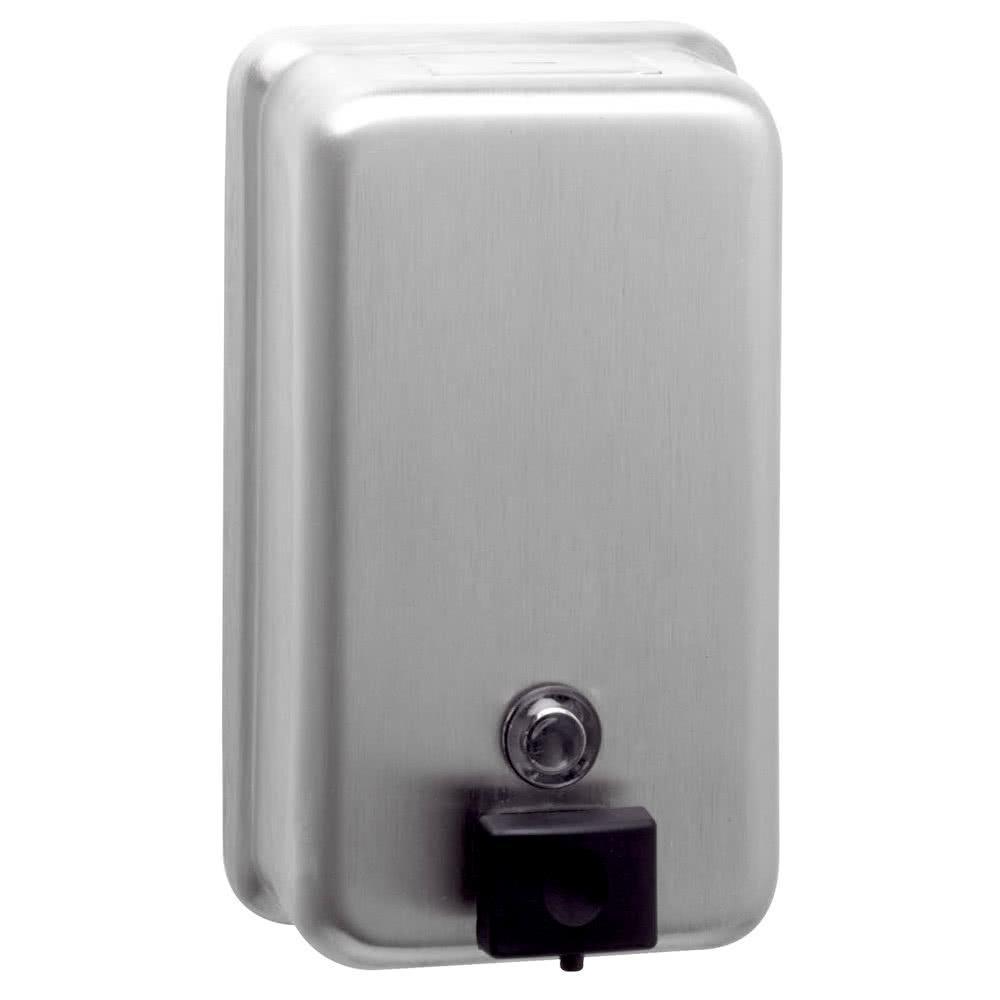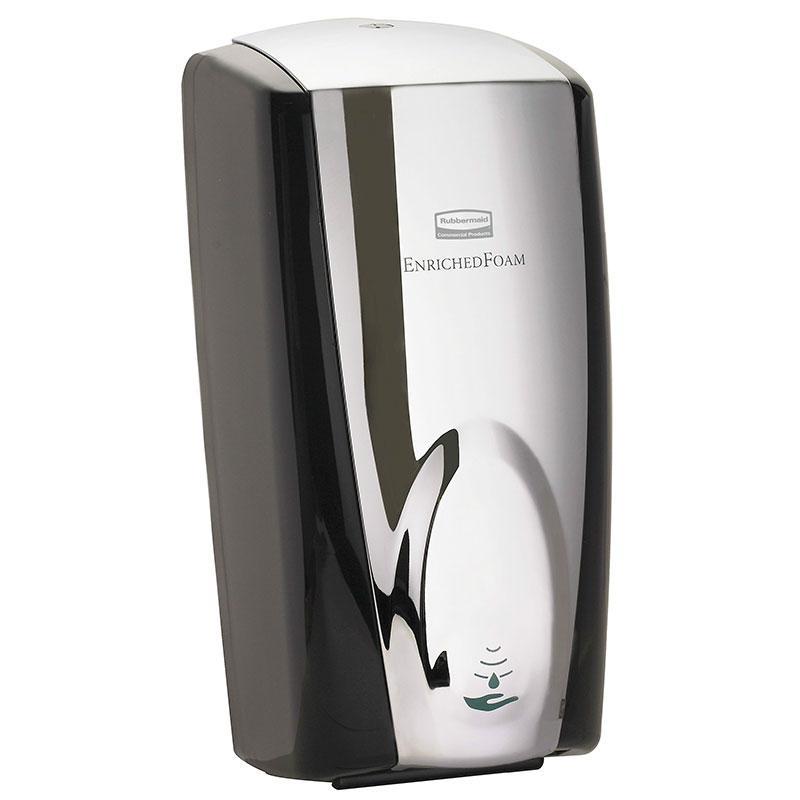The first image is the image on the left, the second image is the image on the right. Evaluate the accuracy of this statement regarding the images: "One soap dispenser has a flat bottom and can be set on a counter.". Is it true? Answer yes or no. No. 